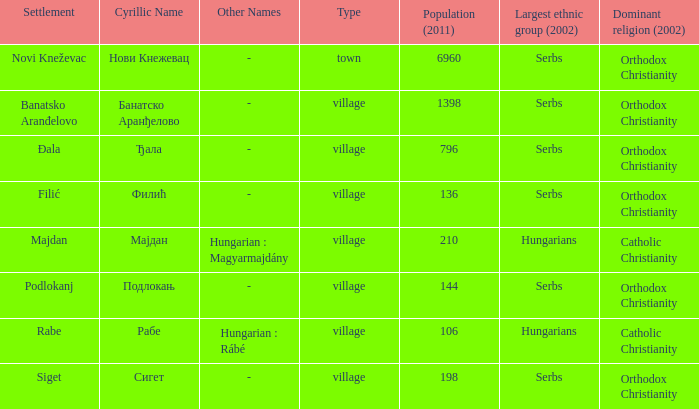Which settlement has the cyrillic name сигет?  Siget. 